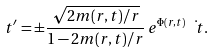Convert formula to latex. <formula><loc_0><loc_0><loc_500><loc_500>\ t ^ { \prime } = \pm \frac { \sqrt { 2 m ( r , t ) / r } } { 1 - 2 m ( r , t ) / r } \, e ^ { \Phi ( r , t ) } \, \dot { \ t } .</formula> 